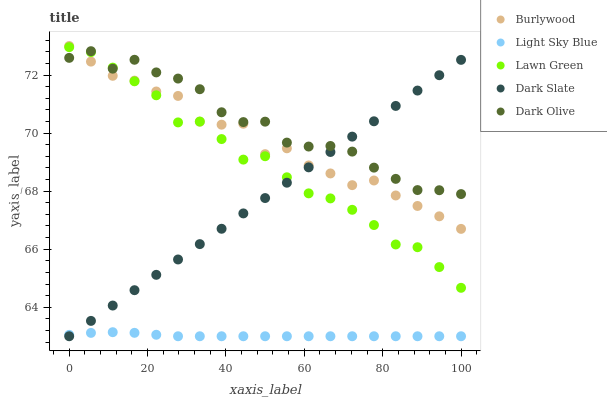Does Light Sky Blue have the minimum area under the curve?
Answer yes or no. Yes. Does Dark Olive have the maximum area under the curve?
Answer yes or no. Yes. Does Lawn Green have the minimum area under the curve?
Answer yes or no. No. Does Lawn Green have the maximum area under the curve?
Answer yes or no. No. Is Dark Slate the smoothest?
Answer yes or no. Yes. Is Burlywood the roughest?
Answer yes or no. Yes. Is Lawn Green the smoothest?
Answer yes or no. No. Is Lawn Green the roughest?
Answer yes or no. No. Does Light Sky Blue have the lowest value?
Answer yes or no. Yes. Does Lawn Green have the lowest value?
Answer yes or no. No. Does Burlywood have the highest value?
Answer yes or no. Yes. Does Lawn Green have the highest value?
Answer yes or no. No. Is Light Sky Blue less than Burlywood?
Answer yes or no. Yes. Is Burlywood greater than Light Sky Blue?
Answer yes or no. Yes. Does Dark Slate intersect Lawn Green?
Answer yes or no. Yes. Is Dark Slate less than Lawn Green?
Answer yes or no. No. Is Dark Slate greater than Lawn Green?
Answer yes or no. No. Does Light Sky Blue intersect Burlywood?
Answer yes or no. No. 